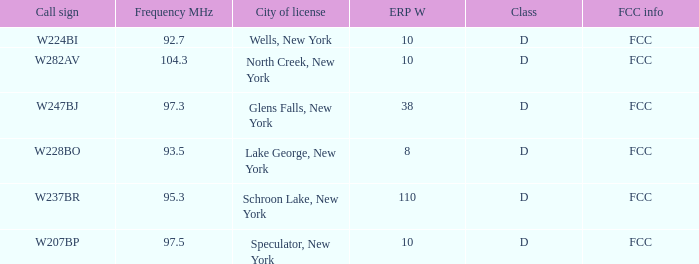Name the ERP W for glens falls, new york 38.0. 